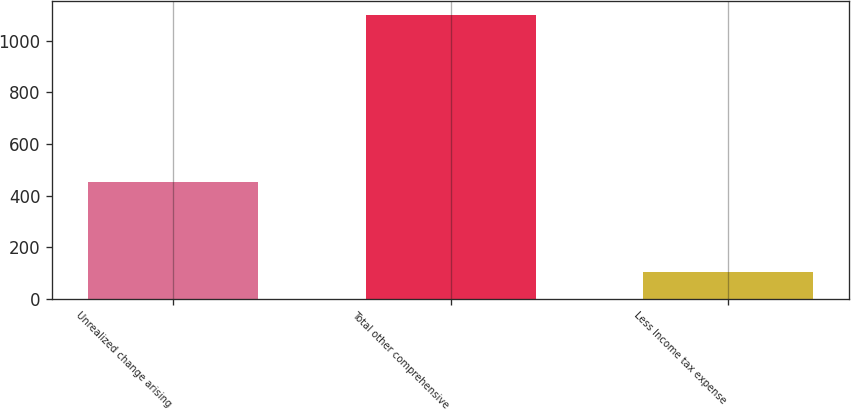Convert chart to OTSL. <chart><loc_0><loc_0><loc_500><loc_500><bar_chart><fcel>Unrealized change arising<fcel>Total other comprehensive<fcel>Less Income tax expense<nl><fcel>454<fcel>1100<fcel>102<nl></chart> 